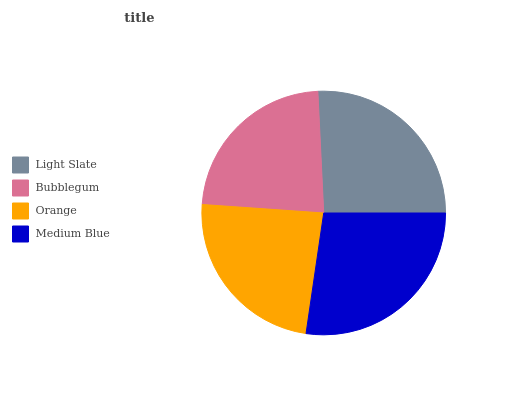Is Bubblegum the minimum?
Answer yes or no. Yes. Is Medium Blue the maximum?
Answer yes or no. Yes. Is Orange the minimum?
Answer yes or no. No. Is Orange the maximum?
Answer yes or no. No. Is Orange greater than Bubblegum?
Answer yes or no. Yes. Is Bubblegum less than Orange?
Answer yes or no. Yes. Is Bubblegum greater than Orange?
Answer yes or no. No. Is Orange less than Bubblegum?
Answer yes or no. No. Is Light Slate the high median?
Answer yes or no. Yes. Is Orange the low median?
Answer yes or no. Yes. Is Orange the high median?
Answer yes or no. No. Is Bubblegum the low median?
Answer yes or no. No. 